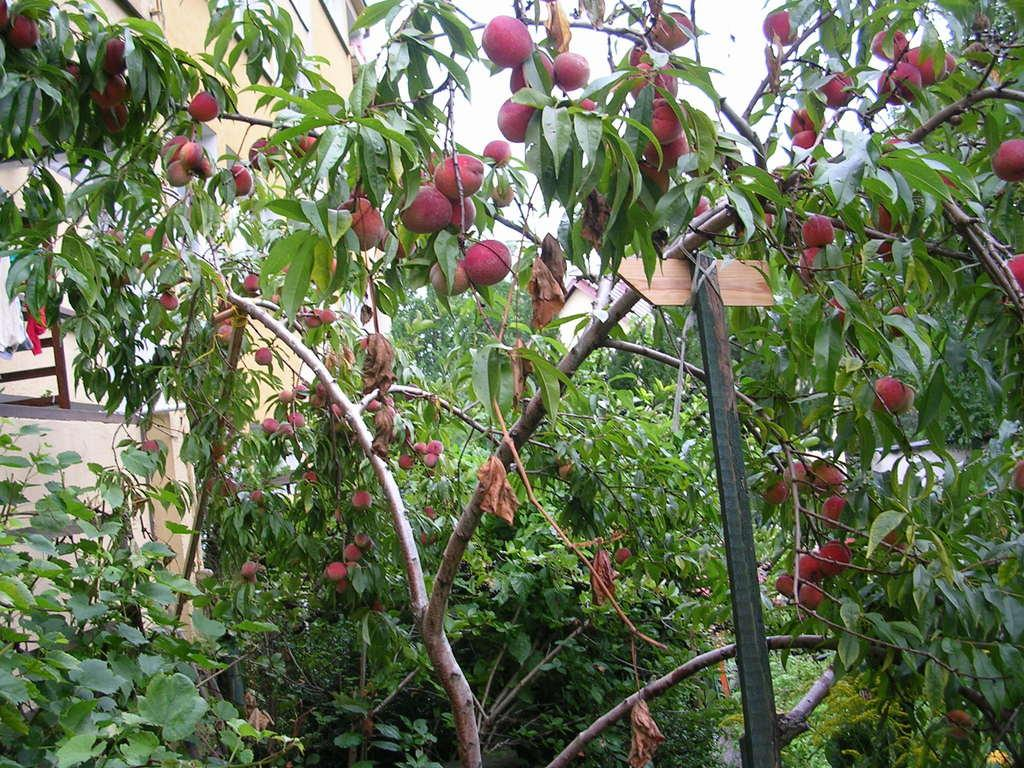What type of fruit can be seen on the trees in the image? There are apples on the trees in the image. What structures can be seen in the background of the image? There is a building, a shed, and a pole in the background of the image. What is visible at the top of the image? The sky is visible at the top of the image. What type of button can be seen on the person in the image? There is no person present in the image, so there is no button to be seen. 